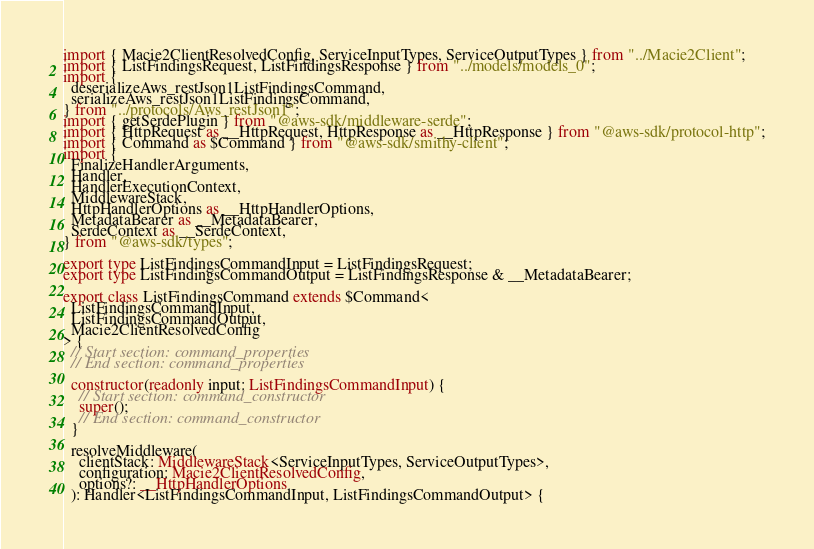<code> <loc_0><loc_0><loc_500><loc_500><_TypeScript_>import { Macie2ClientResolvedConfig, ServiceInputTypes, ServiceOutputTypes } from "../Macie2Client";
import { ListFindingsRequest, ListFindingsResponse } from "../models/models_0";
import {
  deserializeAws_restJson1ListFindingsCommand,
  serializeAws_restJson1ListFindingsCommand,
} from "../protocols/Aws_restJson1";
import { getSerdePlugin } from "@aws-sdk/middleware-serde";
import { HttpRequest as __HttpRequest, HttpResponse as __HttpResponse } from "@aws-sdk/protocol-http";
import { Command as $Command } from "@aws-sdk/smithy-client";
import {
  FinalizeHandlerArguments,
  Handler,
  HandlerExecutionContext,
  MiddlewareStack,
  HttpHandlerOptions as __HttpHandlerOptions,
  MetadataBearer as __MetadataBearer,
  SerdeContext as __SerdeContext,
} from "@aws-sdk/types";

export type ListFindingsCommandInput = ListFindingsRequest;
export type ListFindingsCommandOutput = ListFindingsResponse & __MetadataBearer;

export class ListFindingsCommand extends $Command<
  ListFindingsCommandInput,
  ListFindingsCommandOutput,
  Macie2ClientResolvedConfig
> {
  // Start section: command_properties
  // End section: command_properties

  constructor(readonly input: ListFindingsCommandInput) {
    // Start section: command_constructor
    super();
    // End section: command_constructor
  }

  resolveMiddleware(
    clientStack: MiddlewareStack<ServiceInputTypes, ServiceOutputTypes>,
    configuration: Macie2ClientResolvedConfig,
    options?: __HttpHandlerOptions
  ): Handler<ListFindingsCommandInput, ListFindingsCommandOutput> {</code> 